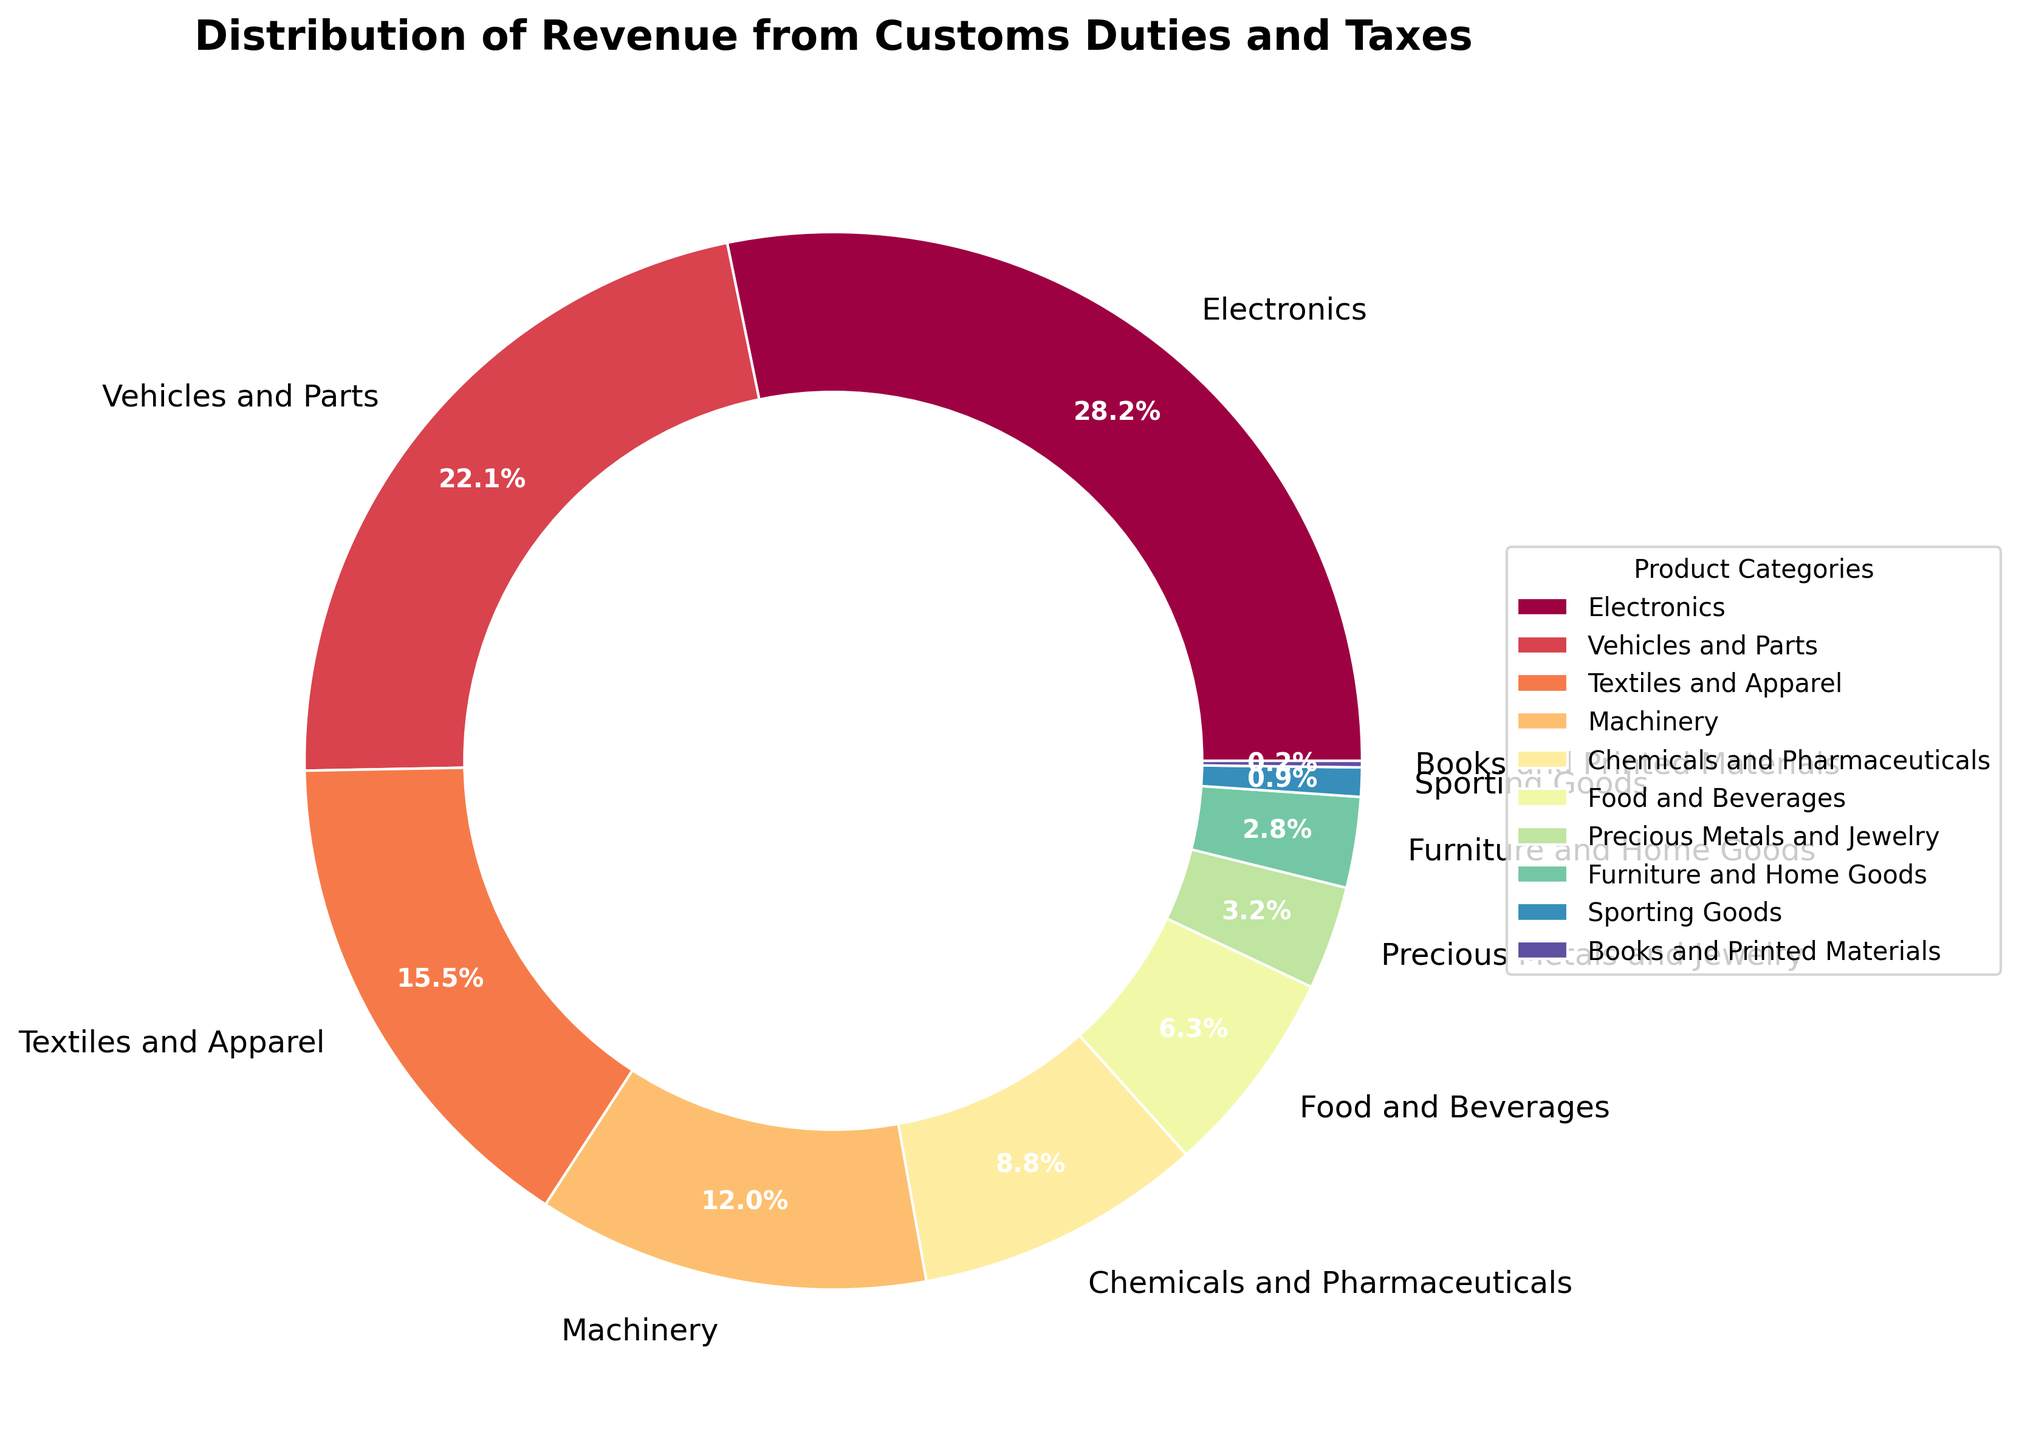What product category generates the highest revenue? Identify the category with the largest slice in the pie chart. The label shows "Electronics" with 28.5%, the highest percentage.
Answer: Electronics What is the difference in revenue percentage between Electronics and Vehicles and Parts? Subtract the percentage of Vehicles and Parts from Electronics: 28.5% – 22.3% = 6.2%.
Answer: 6.2% Which category has a smaller revenue contribution, Food and Beverages, or Chemicals and Pharmaceuticals? Compare the slices labeled "Food and Beverages" (6.4%) and "Chemicals and Pharmaceuticals" (8.9%) in the pie chart. Food and Beverages is smaller.
Answer: Food and Beverages What is the combined revenue percentage for Textiles and Apparel, and Machinery? Add the percentages of Textiles and Apparel (15.7%) and Machinery (12.1%): 15.7% + 12.1% = 27.8%.
Answer: 27.8% How many categories contribute less than 2% of the total revenue? Identify the slices with percentages less than 2%: Sporting Goods (0.9%) and Books and Printed Materials (0.2%), which makes two categories.
Answer: 2 What is the revenue contribution of Precious Metals and Jewelry relative to Electronics? Divide the revenue percentage of Precious Metals and Jewelry (3.2%) by Electronics (28.5%): 3.2 / 28.5 ≈ 0.112 or 11.2%.
Answer: 11.2% Which categories together make up more than half (over 50%) of the total revenue? Sum the largest categories starting from the highest percentage until it exceeds 50%: Electronics (28.5%) + Vehicles and Parts (22.3%) = 50.8%.
Answer: Electronics and Vehicles and Parts What is the revenue percentage difference between the smallest and largest categories? Subtract the percentage of the smallest category (Books and Printed Materials, 0.2%) from the largest category (Electronics, 28.5%): 28.5% - 0.2% = 28.3%.
Answer: 28.3% Which product categories have revenue contributions between 5% and 10%? Identify slices with percentages within the 5% to 10% range: Chemicals and Pharmaceuticals (8.9%) and Food and Beverages (6.4%).
Answer: Chemicals and Pharmaceuticals and Food and Beverages What is the average revenue percentage of all categories? Sum all the percentages and divide by the number of categories. Total = 100%, and there are 10 categories: 100% / 10 = 10%.
Answer: 10% 